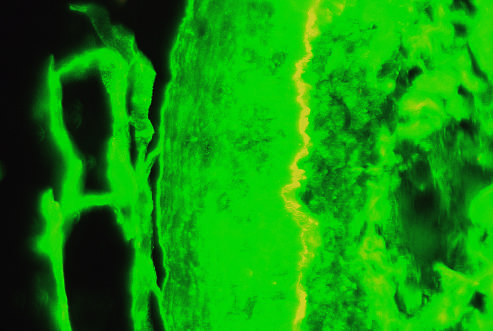s bone marrow on the left side of the fluorescent band?
Answer the question using a single word or phrase. No 